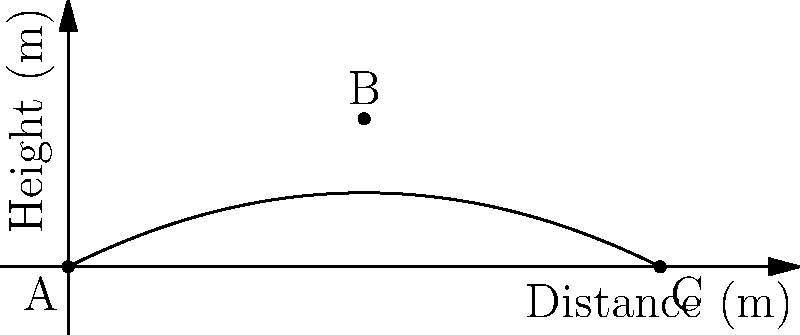During a football match in Buzanada, a player kicks the ball, and its trajectory follows the parabolic path shown in the graph. If the ball travels a total horizontal distance of 10 meters, what is the maximum height reached by the ball? To find the maximum height of the ball's trajectory, we need to follow these steps:

1. Identify the shape of the trajectory: The path is a parabola, which is symmetric.

2. Locate the vertex: The highest point of the parabola (vertex) occurs at the midpoint of the horizontal distance.
   Horizontal distance = 10 m
   Midpoint = 10 m ÷ 2 = 5 m

3. Read the graph: At the 5 m mark on the x-axis (distance), we can see that the corresponding y-value (height) is 2.5 m.

4. Verify using the quadratic equation: The path can be described by the equation $y = -ax^2 + bx$, where 'a' and 'b' are constants.
   At x = 0, y = 0
   At x = 10, y = 0
   At x = 5, y = 2.5

   We can confirm that the maximum height occurs at x = 5 m and y = 2.5 m.

Therefore, the maximum height reached by the ball is 2.5 meters.
Answer: 2.5 meters 